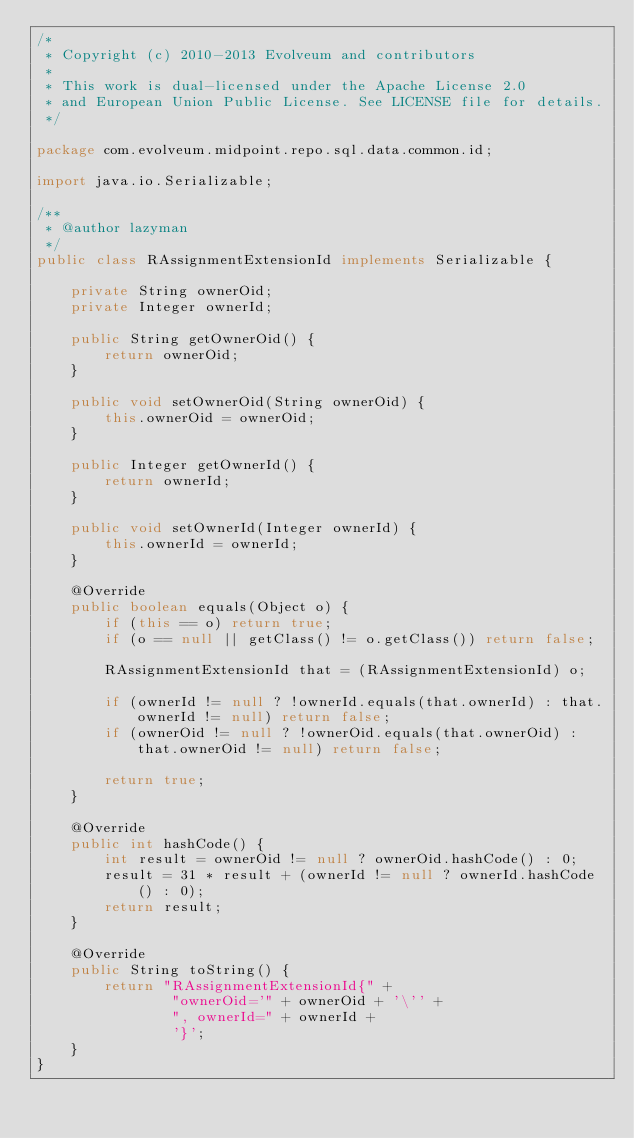Convert code to text. <code><loc_0><loc_0><loc_500><loc_500><_Java_>/*
 * Copyright (c) 2010-2013 Evolveum and contributors
 *
 * This work is dual-licensed under the Apache License 2.0
 * and European Union Public License. See LICENSE file for details.
 */

package com.evolveum.midpoint.repo.sql.data.common.id;

import java.io.Serializable;

/**
 * @author lazyman
 */
public class RAssignmentExtensionId implements Serializable {

    private String ownerOid;
    private Integer ownerId;

    public String getOwnerOid() {
        return ownerOid;
    }

    public void setOwnerOid(String ownerOid) {
        this.ownerOid = ownerOid;
    }

    public Integer getOwnerId() {
        return ownerId;
    }

    public void setOwnerId(Integer ownerId) {
        this.ownerId = ownerId;
    }

    @Override
    public boolean equals(Object o) {
        if (this == o) return true;
        if (o == null || getClass() != o.getClass()) return false;

        RAssignmentExtensionId that = (RAssignmentExtensionId) o;

        if (ownerId != null ? !ownerId.equals(that.ownerId) : that.ownerId != null) return false;
        if (ownerOid != null ? !ownerOid.equals(that.ownerOid) : that.ownerOid != null) return false;

        return true;
    }

    @Override
    public int hashCode() {
        int result = ownerOid != null ? ownerOid.hashCode() : 0;
        result = 31 * result + (ownerId != null ? ownerId.hashCode() : 0);
        return result;
    }

    @Override
    public String toString() {
        return "RAssignmentExtensionId{" +
                "ownerOid='" + ownerOid + '\'' +
                ", ownerId=" + ownerId +
                '}';
    }
}
</code> 